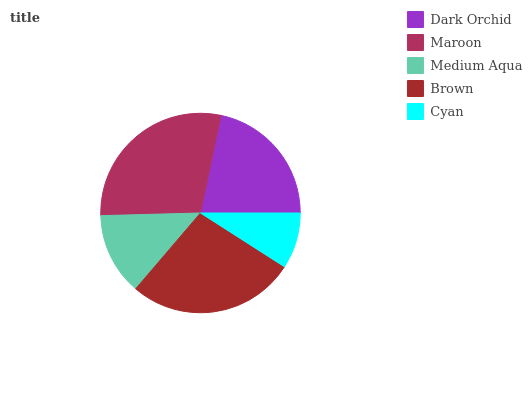Is Cyan the minimum?
Answer yes or no. Yes. Is Maroon the maximum?
Answer yes or no. Yes. Is Medium Aqua the minimum?
Answer yes or no. No. Is Medium Aqua the maximum?
Answer yes or no. No. Is Maroon greater than Medium Aqua?
Answer yes or no. Yes. Is Medium Aqua less than Maroon?
Answer yes or no. Yes. Is Medium Aqua greater than Maroon?
Answer yes or no. No. Is Maroon less than Medium Aqua?
Answer yes or no. No. Is Dark Orchid the high median?
Answer yes or no. Yes. Is Dark Orchid the low median?
Answer yes or no. Yes. Is Cyan the high median?
Answer yes or no. No. Is Maroon the low median?
Answer yes or no. No. 